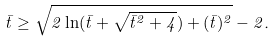<formula> <loc_0><loc_0><loc_500><loc_500>\bar { t } \geq \sqrt { 2 \ln ( \bar { t } + \sqrt { \bar { t } ^ { 2 } + 4 } ) + ( \bar { t } ) ^ { 2 } } - 2 .</formula> 